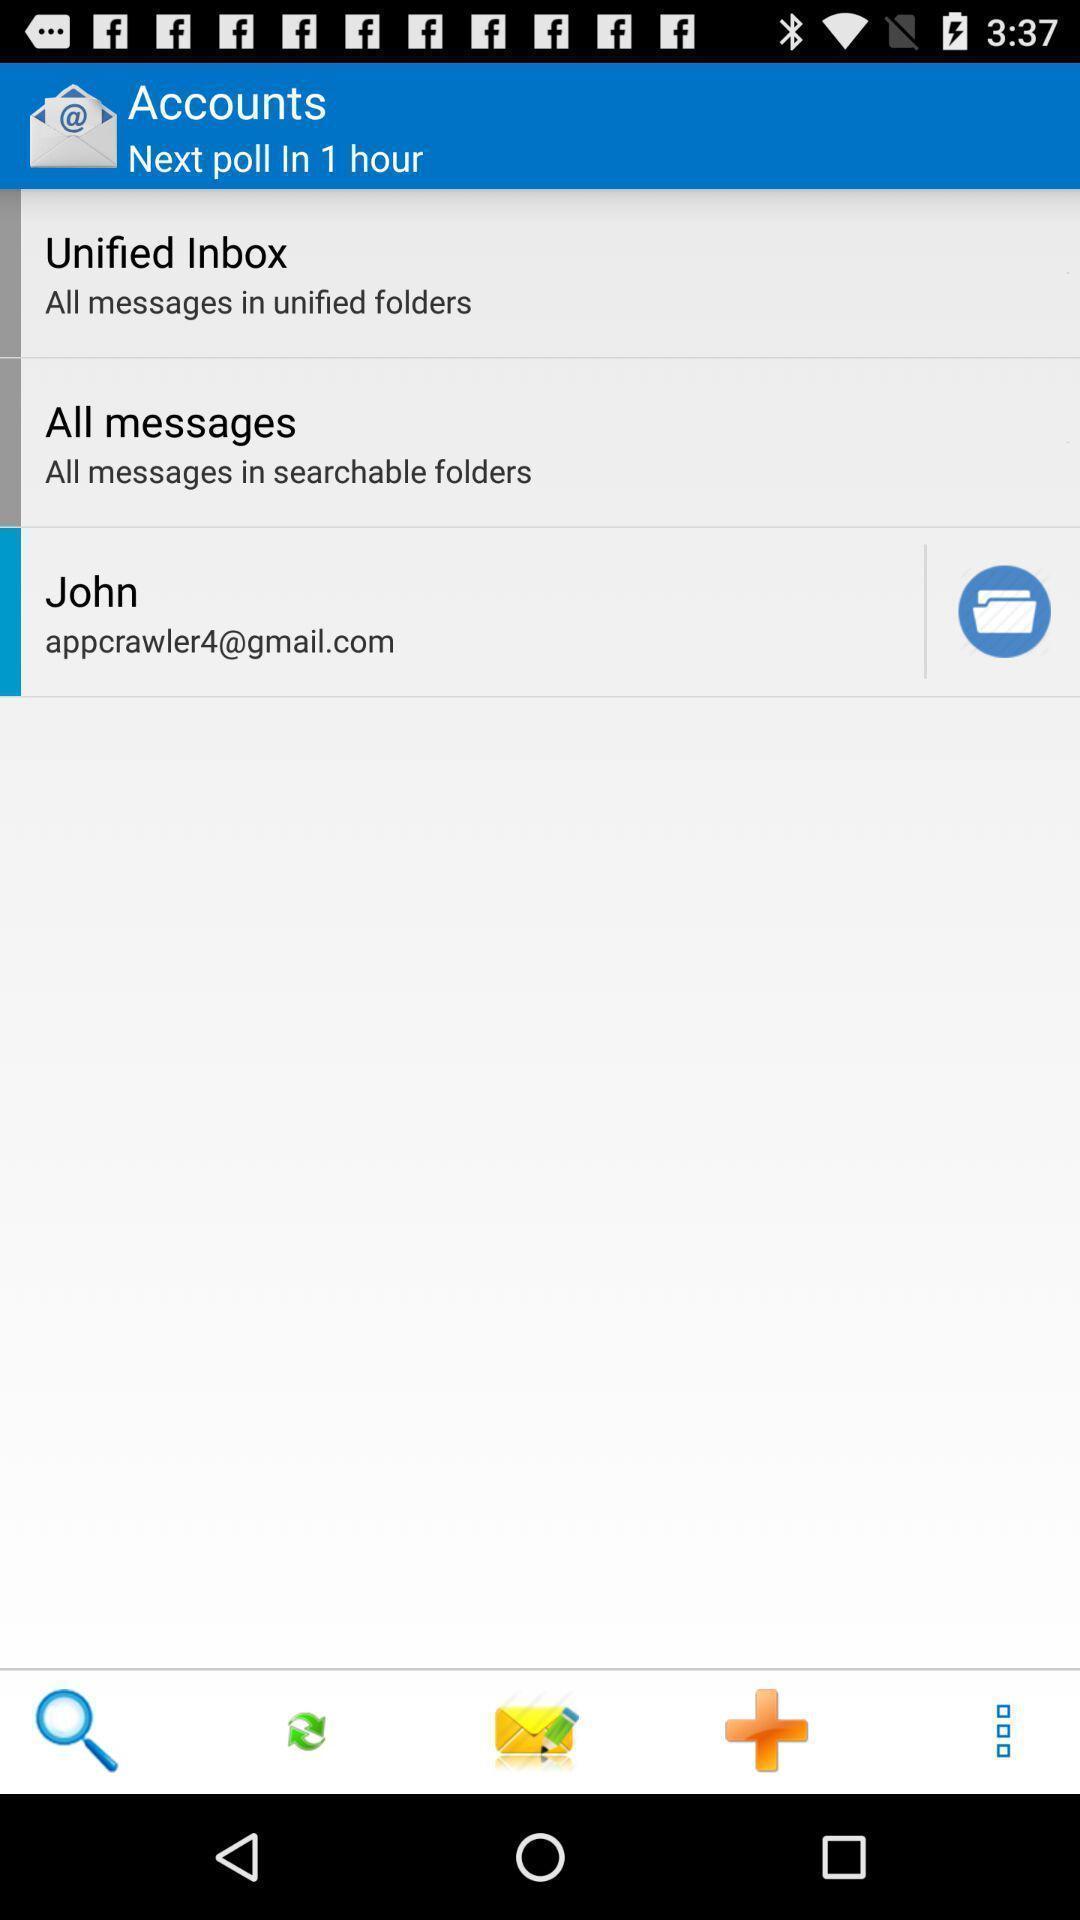Give me a summary of this screen capture. Screen displaying the list of folders in accounts page. 